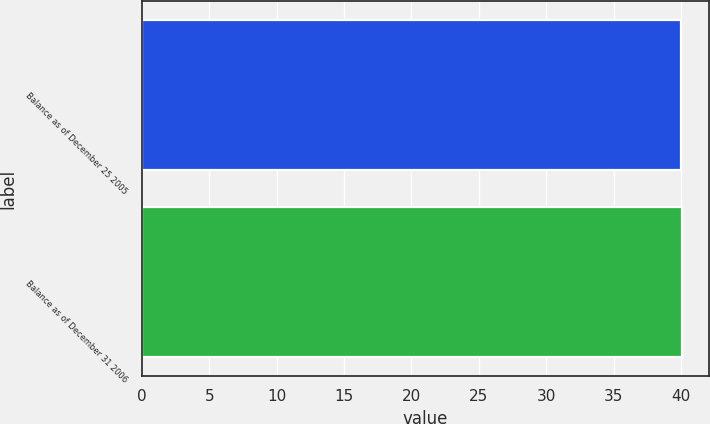<chart> <loc_0><loc_0><loc_500><loc_500><bar_chart><fcel>Balance as of December 25 2005<fcel>Balance as of December 31 2006<nl><fcel>40<fcel>40.1<nl></chart> 